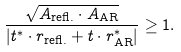<formula> <loc_0><loc_0><loc_500><loc_500>\frac { \sqrt { A _ { \text {refl.} } \cdot A _ { \text {AR} } } } { | t ^ { \ast } \cdot r _ { \text {refl.} } + t \cdot r _ { \text {AR} } ^ { \ast } | } \geq 1 .</formula> 